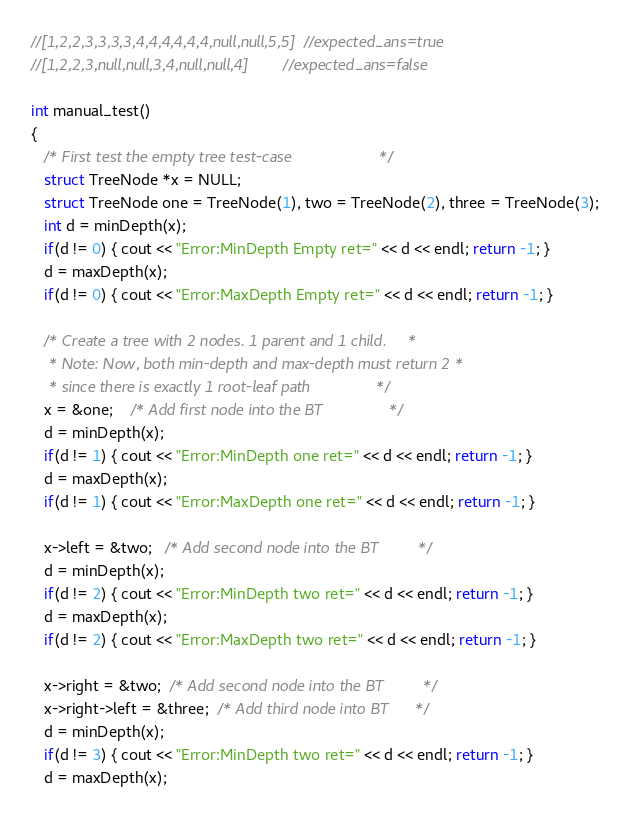Convert code to text. <code><loc_0><loc_0><loc_500><loc_500><_C++_>//[1,2,2,3,3,3,3,4,4,4,4,4,4,null,null,5,5]  //expected_ans=true
//[1,2,2,3,null,null,3,4,null,null,4]        //expected_ans=false

int manual_test()
{
   /* First test the empty tree test-case                    */
   struct TreeNode *x = NULL;
   struct TreeNode one = TreeNode(1), two = TreeNode(2), three = TreeNode(3);
   int d = minDepth(x);
   if(d != 0) { cout << "Error:MinDepth Empty ret=" << d << endl; return -1; }
   d = maxDepth(x);
   if(d != 0) { cout << "Error:MaxDepth Empty ret=" << d << endl; return -1; }

   /* Create a tree with 2 nodes. 1 parent and 1 child.     *
    * Note: Now, both min-depth and max-depth must return 2 *
    * since there is exactly 1 root-leaf path               */
   x = &one;    /* Add first node into the BT               */
   d = minDepth(x);
   if(d != 1) { cout << "Error:MinDepth one ret=" << d << endl; return -1; }
   d = maxDepth(x);
   if(d != 1) { cout << "Error:MaxDepth one ret=" << d << endl; return -1; }

   x->left = &two;   /* Add second node into the BT         */
   d = minDepth(x);
   if(d != 2) { cout << "Error:MinDepth two ret=" << d << endl; return -1; }
   d = maxDepth(x);
   if(d != 2) { cout << "Error:MaxDepth two ret=" << d << endl; return -1; }

   x->right = &two;  /* Add second node into the BT         */
   x->right->left = &three;  /* Add third node into BT      */
   d = minDepth(x);
   if(d != 3) { cout << "Error:MinDepth two ret=" << d << endl; return -1; }
   d = maxDepth(x);</code> 